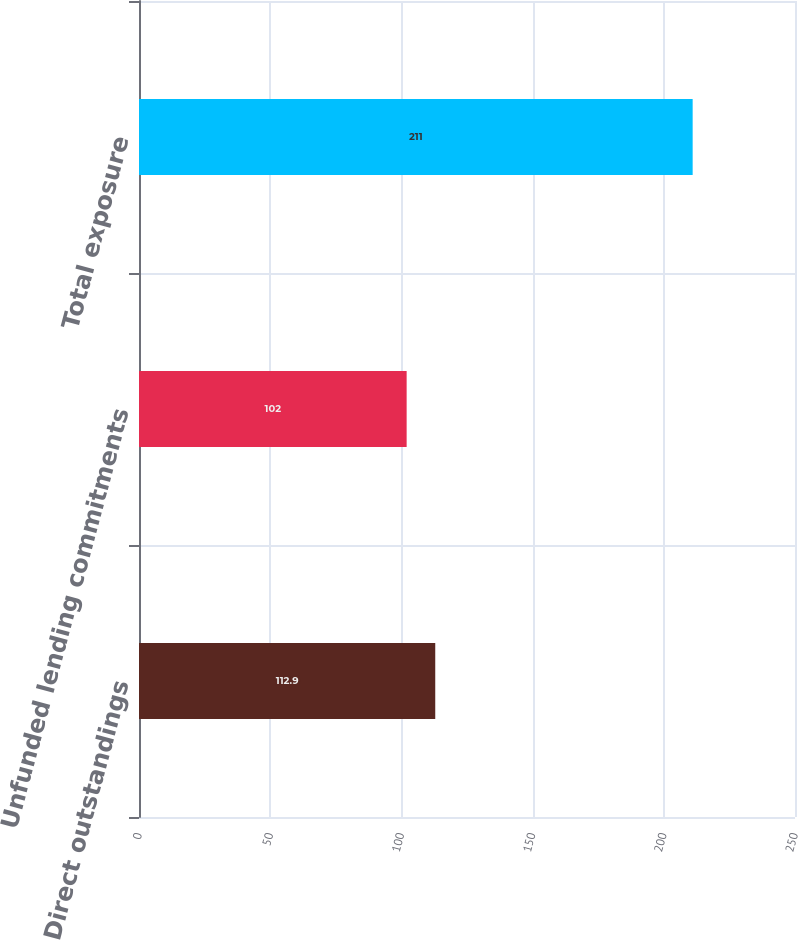Convert chart. <chart><loc_0><loc_0><loc_500><loc_500><bar_chart><fcel>Direct outstandings<fcel>Unfunded lending commitments<fcel>Total exposure<nl><fcel>112.9<fcel>102<fcel>211<nl></chart> 